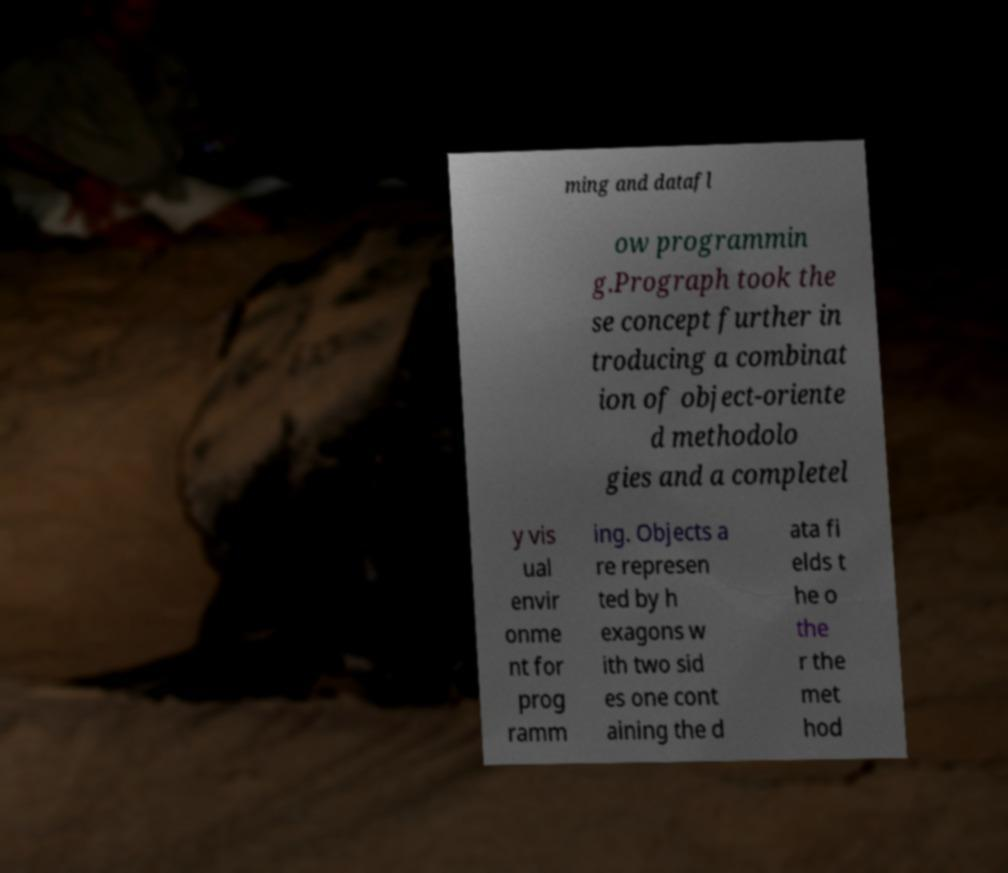Could you assist in decoding the text presented in this image and type it out clearly? ming and datafl ow programmin g.Prograph took the se concept further in troducing a combinat ion of object-oriente d methodolo gies and a completel y vis ual envir onme nt for prog ramm ing. Objects a re represen ted by h exagons w ith two sid es one cont aining the d ata fi elds t he o the r the met hod 